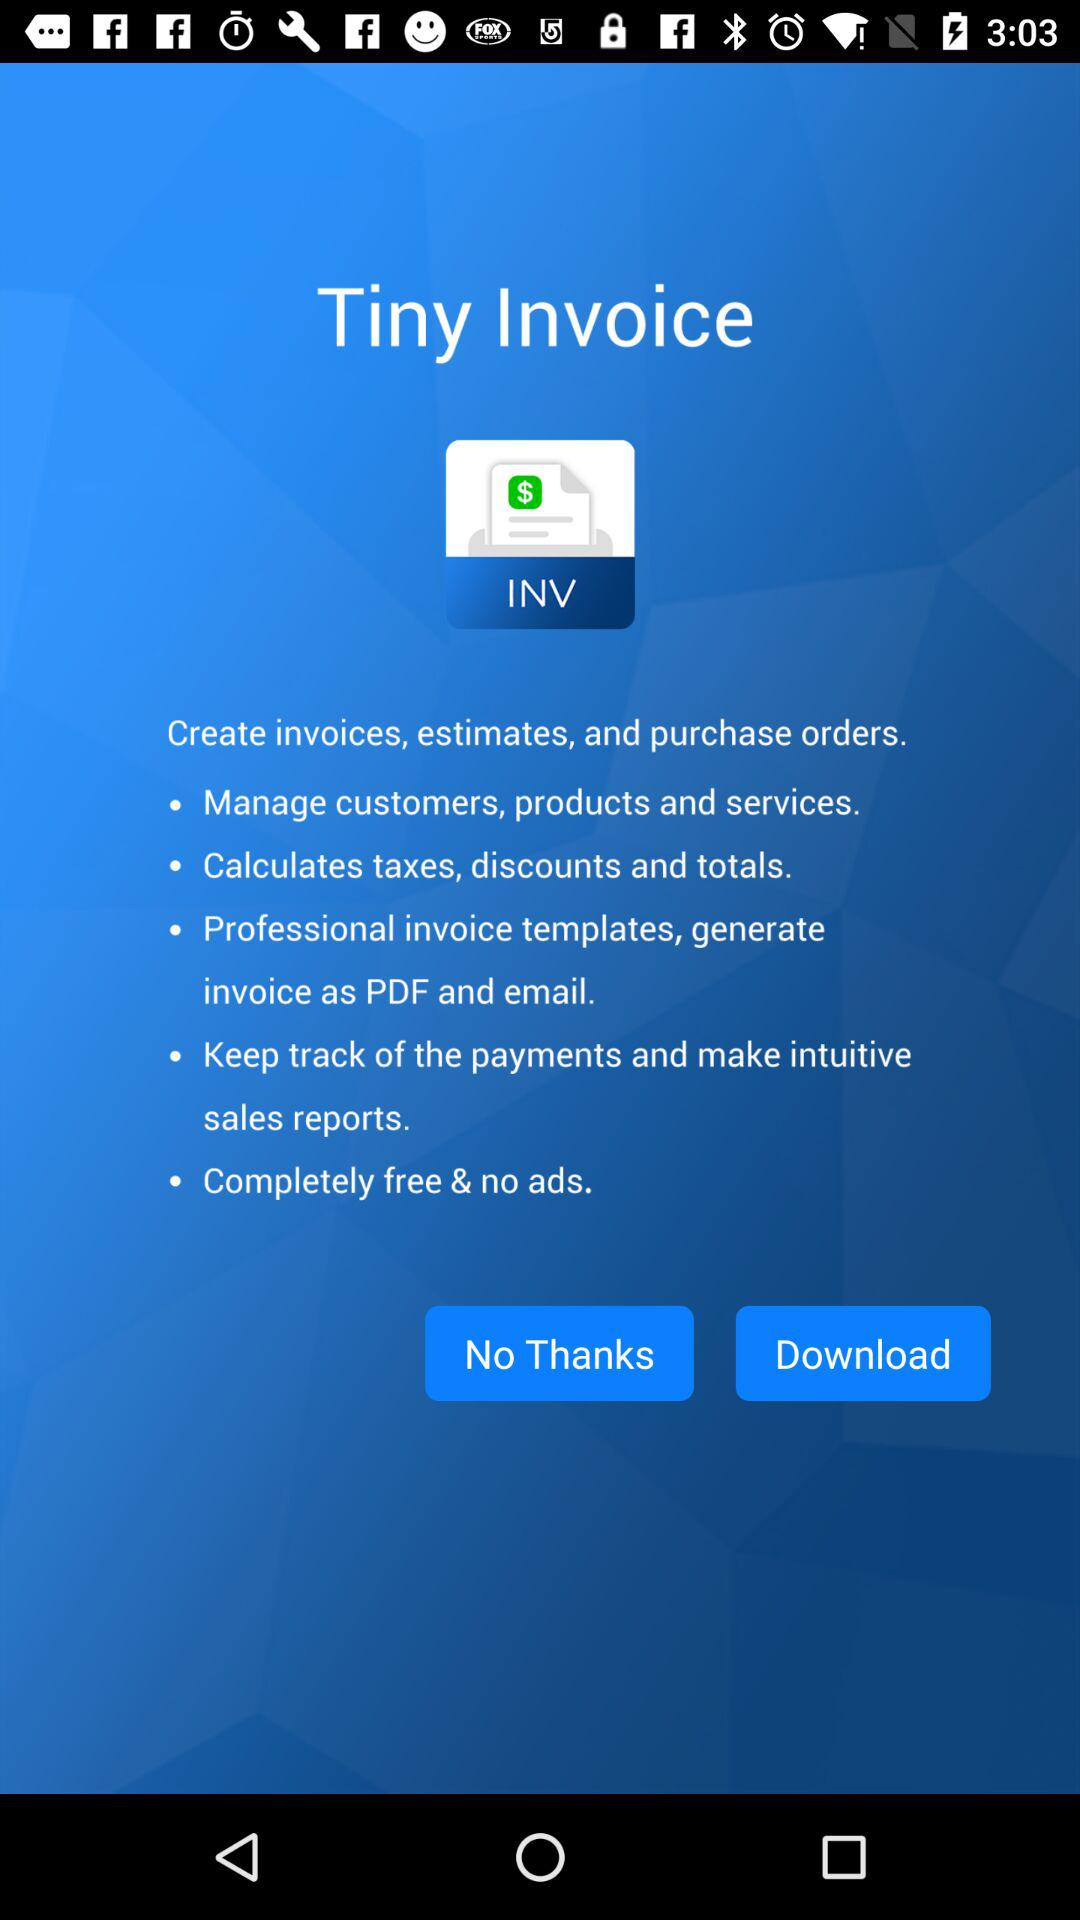"Tiny Invoice" is powered by who?
When the provided information is insufficient, respond with <no answer>. <no answer> 